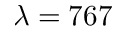Convert formula to latex. <formula><loc_0><loc_0><loc_500><loc_500>\lambda = 7 6 7</formula> 